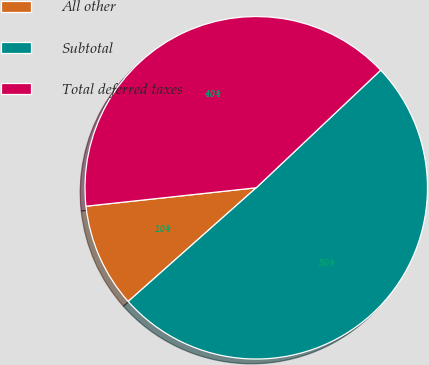<chart> <loc_0><loc_0><loc_500><loc_500><pie_chart><fcel>All other<fcel>Subtotal<fcel>Total deferred taxes<nl><fcel>9.84%<fcel>50.49%<fcel>39.67%<nl></chart> 